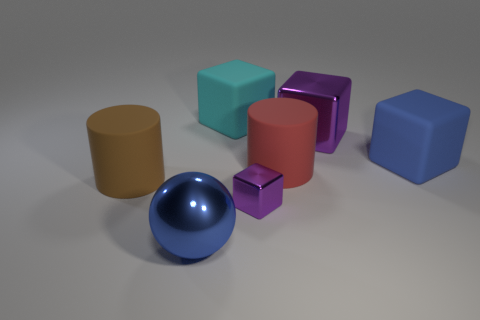Subtract all blue cubes. How many cubes are left? 3 Subtract all brown cylinders. How many cylinders are left? 1 Subtract all cylinders. How many objects are left? 5 Subtract 1 cylinders. How many cylinders are left? 1 Subtract all purple cylinders. How many red blocks are left? 0 Subtract 0 brown balls. How many objects are left? 7 Subtract all cyan cubes. Subtract all red cylinders. How many cubes are left? 3 Subtract all large red matte things. Subtract all large cubes. How many objects are left? 3 Add 2 small shiny objects. How many small shiny objects are left? 3 Add 5 large yellow metal cylinders. How many large yellow metal cylinders exist? 5 